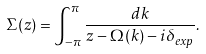<formula> <loc_0><loc_0><loc_500><loc_500>\Sigma ( z ) = \int _ { - \pi } ^ { \pi } \frac { d k } { z - \Omega ( k ) - i \delta _ { e x p } } .</formula> 